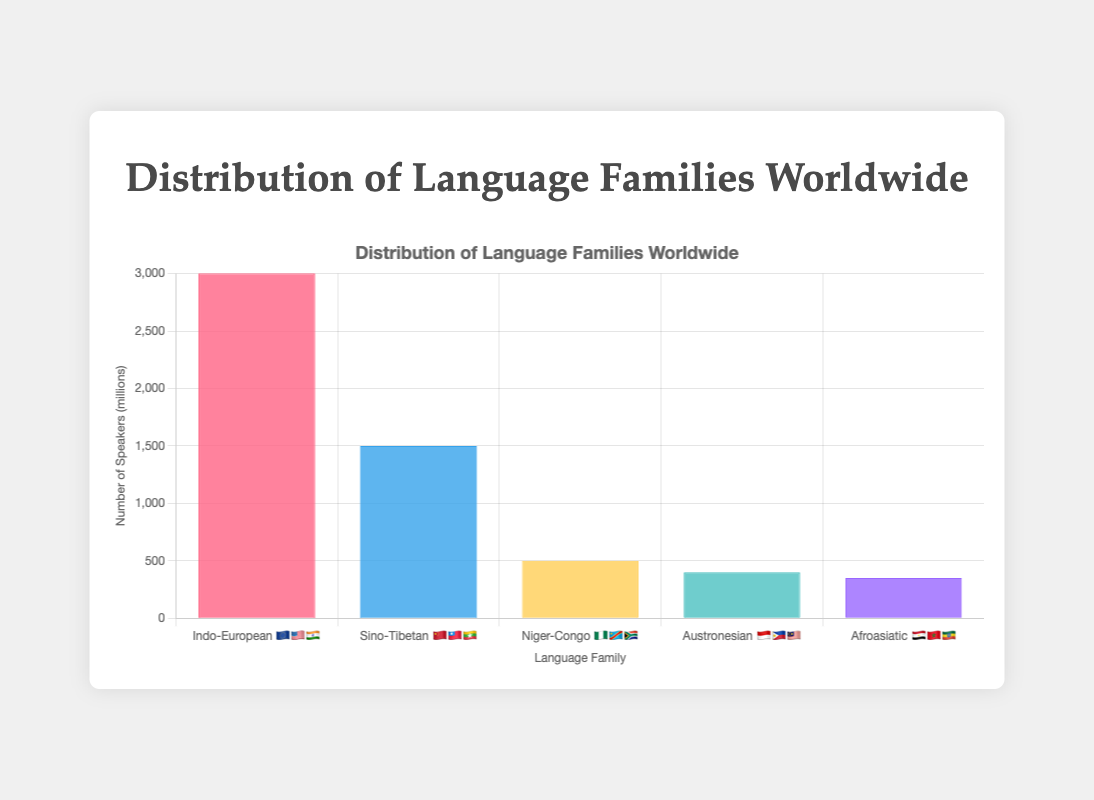Which language family has the highest number of speakers? The bar chart shows the number of speakers for each language family. The Indo-European family has the tallest bar, indicating it has the highest number of speakers at 3000 million.
Answer: Indo-European Which regions are associated with the Sino-Tibetan language family? According to the labels on the x-axis, the Sino-Tibetan language family is represented with the flags 🇨🇳🇹🇼🇲🇲, which correspond to China, Taiwan, and Myanmar.
Answer: China, Taiwan, Myanmar How many millions more speakers does the Indo-European language family have compared to the Niger-Congo language family? The Indo-European family's bar indicates 3000 million speakers. The Niger-Congo family's bar indicates 500 million speakers. The difference is 3000 - 500 = 2500 million.
Answer: 2500 million What are the example languages of the Afroasiatic language family? Hovering over the bar for the Afroasiatic family displays a tooltip listing example languages: Arabic, Hebrew, Amharic.
Answer: Arabic, Hebrew, Amharic Which language family has the least number of speakers? Comparing the heights of the bars, the Afroasiatic language family has the shortest bar, indicating it has the least number of speakers at 350 million.
Answer: Afroasiatic What is the combined number of speakers for the Austronesian and Afroasiatic language families? The Austronesian family has 400 million speakers, and the Afroasiatic family has 350 million speakers. Their combined total is 400 + 350 = 750 million.
Answer: 750 million What is the title of the chart? The title of the chart is centered at the top and reads "Distribution of Language Families Worldwide."
Answer: Distribution of Language Families Worldwide In which regions can you find speakers of the Austronesian language family? The Austronesian language family is represented by the flags 🇮🇩🇵🇭🇲🇾 on the x-axis, corresponding to Indonesia, the Philippines, and Malaysia.
Answer: Indonesia, Philippines, Malaysia How many language families are represented in the chart? Counting the distinct bars on the x-axis, there are 5 language families shown in the chart.
Answer: 5 Which language family has approximately three times the number of speakers as the Niger-Congo language family? The Niger-Congo family has 500 million speakers. The Sino-Tibetan family has 1500 million speakers, which is approximately three times 500 million (500 * 3 = 1500).
Answer: Sino-Tibetan 